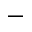<formula> <loc_0><loc_0><loc_500><loc_500>-</formula> 